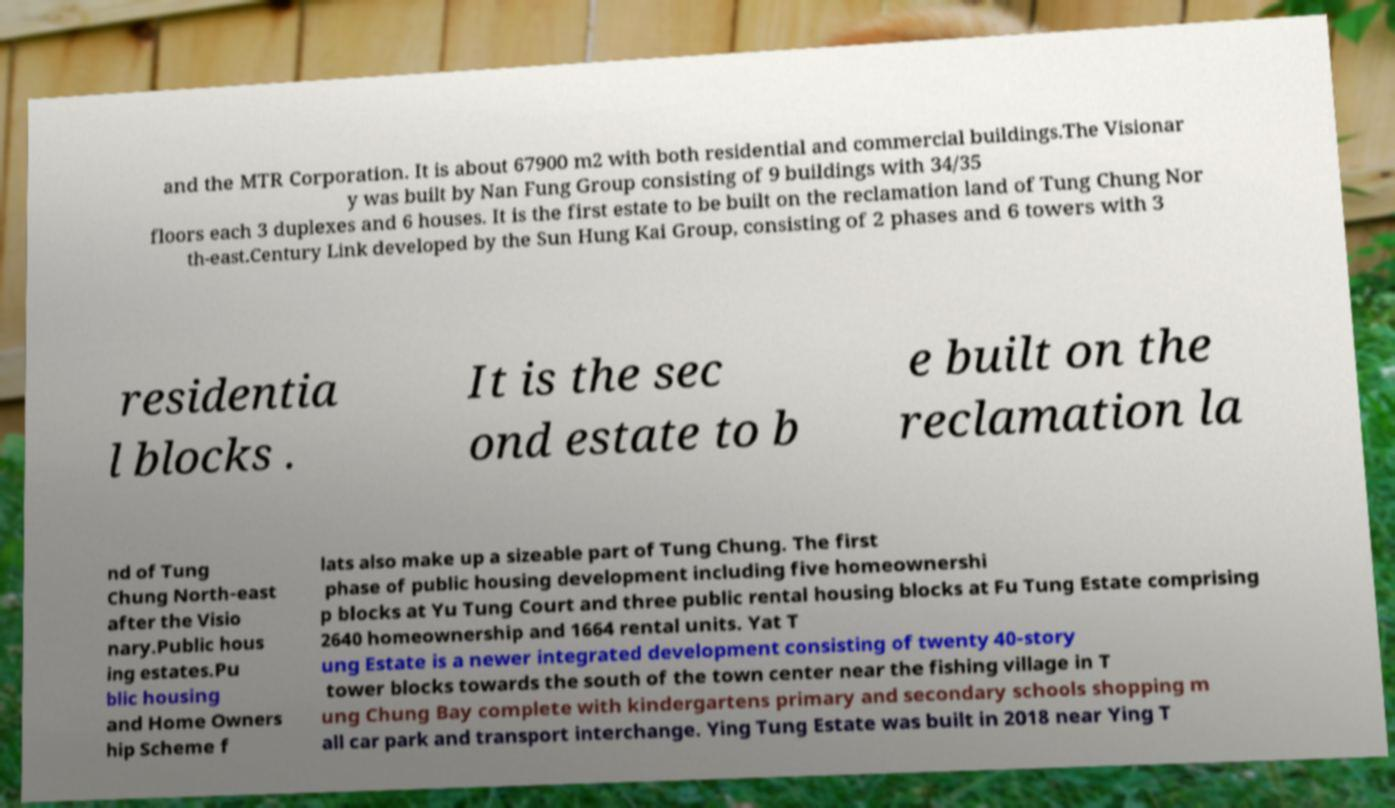For documentation purposes, I need the text within this image transcribed. Could you provide that? and the MTR Corporation. It is about 67900 m2 with both residential and commercial buildings.The Visionar y was built by Nan Fung Group consisting of 9 buildings with 34/35 floors each 3 duplexes and 6 houses. It is the first estate to be built on the reclamation land of Tung Chung Nor th-east.Century Link developed by the Sun Hung Kai Group, consisting of 2 phases and 6 towers with 3 residentia l blocks . It is the sec ond estate to b e built on the reclamation la nd of Tung Chung North-east after the Visio nary.Public hous ing estates.Pu blic housing and Home Owners hip Scheme f lats also make up a sizeable part of Tung Chung. The first phase of public housing development including five homeownershi p blocks at Yu Tung Court and three public rental housing blocks at Fu Tung Estate comprising 2640 homeownership and 1664 rental units. Yat T ung Estate is a newer integrated development consisting of twenty 40-story tower blocks towards the south of the town center near the fishing village in T ung Chung Bay complete with kindergartens primary and secondary schools shopping m all car park and transport interchange. Ying Tung Estate was built in 2018 near Ying T 